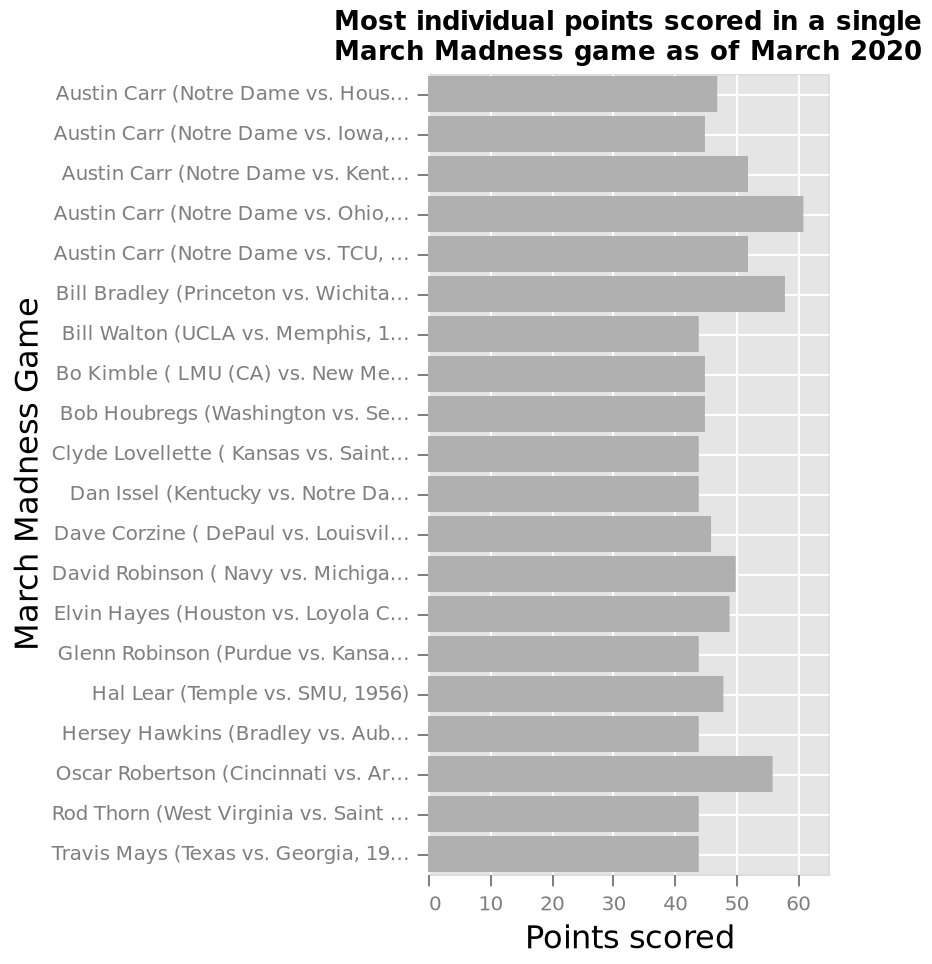<image>
What is the ending point on the y-axis of the bar graph? The ending point on the y-axis is Travis Mays (Texas vs. Georgia, 1990). What is the range of the x-axis in this bar graph? The range of the x-axis is from 0 to 60, representing the points scored in the March Madness games on a linear scale. Offer a thorough analysis of the image. All players have scored over 40 points. The highest points (60) were scored by Austin Carr. Austin Carr has played five seperate games. All others have only played one. 